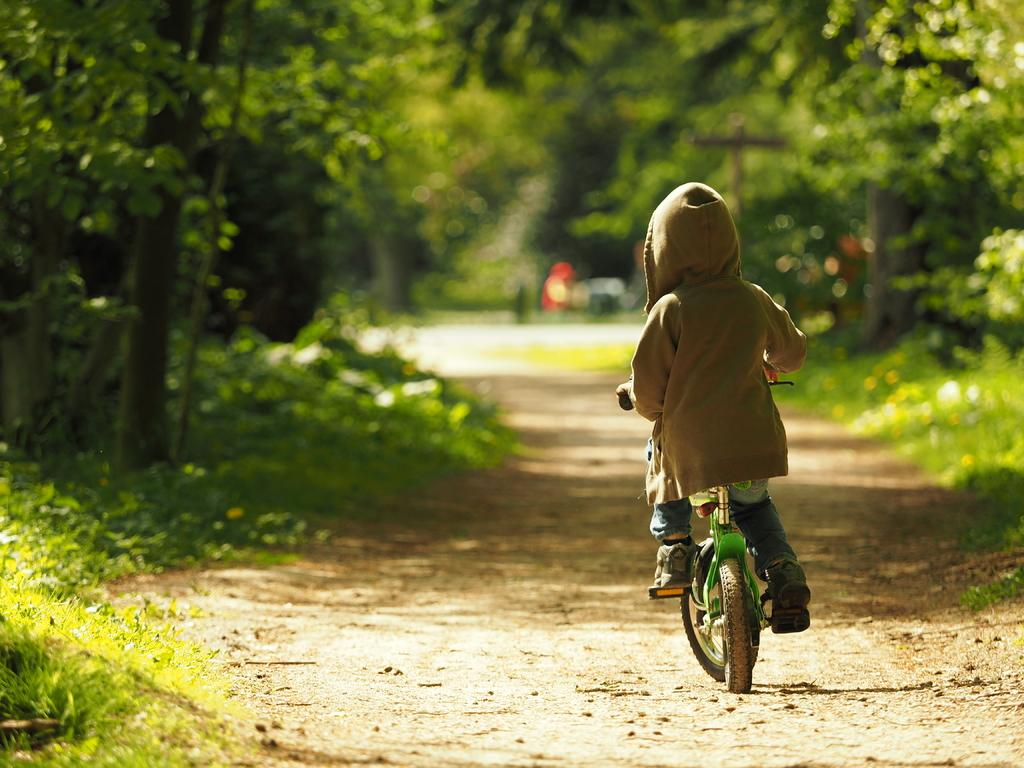What is the person doing in the image? The person is riding a bicycle. What is the person holding while riding the bicycle? The person is holding a handle. What can be observed about the person's clothing in the image? The person is wearing a colorful shirt. What can be seen in the background of the image? There are trees and a road visible in the background. How does the person increase their speed every minute while riding the bicycle in the image? There is no indication in the image that the person is trying to increase their speed or that they are doing so at a specific interval, such as every minute. 